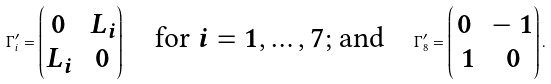Convert formula to latex. <formula><loc_0><loc_0><loc_500><loc_500>\Gamma ^ { \prime } _ { i } = \begin{pmatrix} 0 & L _ { i } \\ L _ { i } & 0 \end{pmatrix} \quad \text {for $i=1,\dots,7$; and} \quad \Gamma ^ { \prime } _ { 8 } = \begin{pmatrix} 0 & - \ 1 \\ \ 1 & 0 \end{pmatrix} .</formula> 